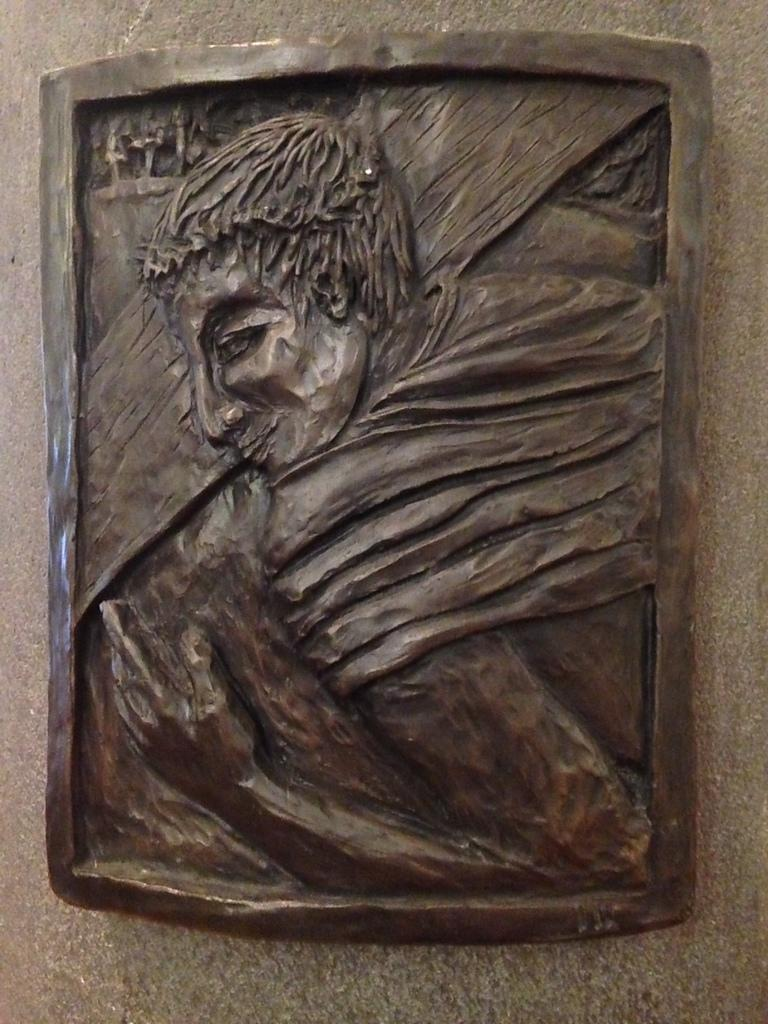What is the main subject in the center of the image? There is a sculpture in the center of the image. Where is the sculpture located? The sculpture is on the wall. What type of clouds can be seen in the image? There are no clouds visible in the image; it features a sculpture on the wall. What color is the train in the image? There is no train present in the image. 